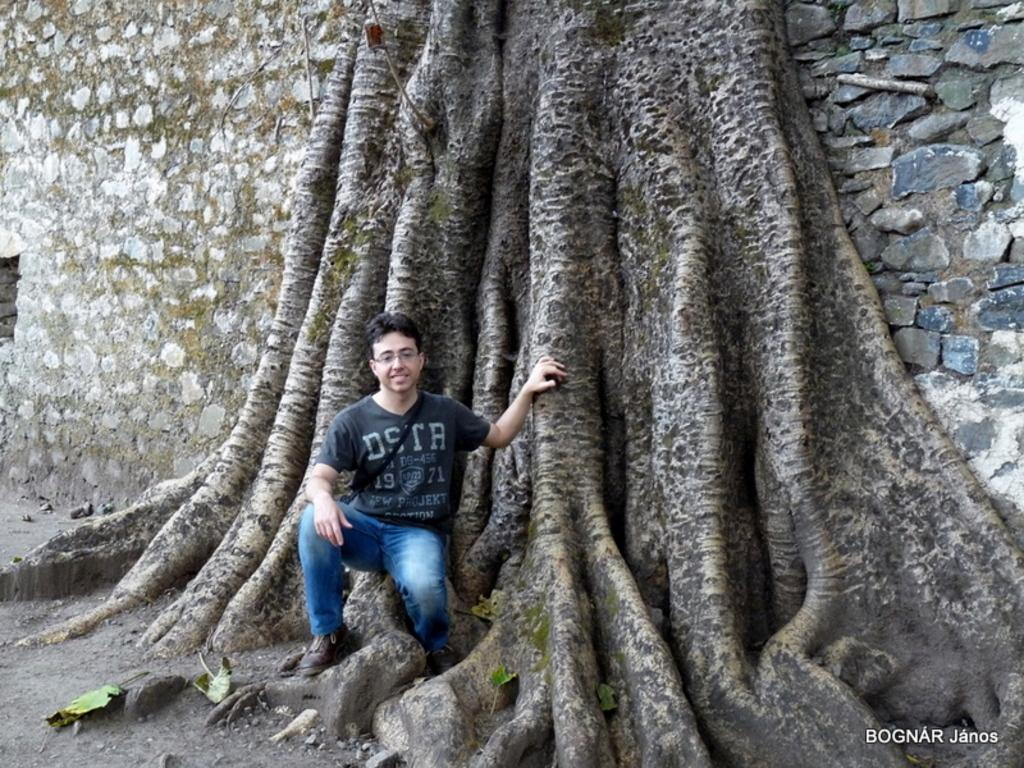What is the main subject in the foreground of the image? There is a man in the foreground of the image. What is the man doing in the image? The man is squatting in the image. What can be seen in the background of the image? There is a tree trunk and a brick wall in the background of the image. What type of vein is visible on the tree trunk in the image? There are no veins visible on the tree trunk in the image, as trees do not have veins like animals do. 